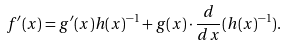Convert formula to latex. <formula><loc_0><loc_0><loc_500><loc_500>f ^ { \prime } ( x ) = g ^ { \prime } ( x ) h ( x ) ^ { - 1 } + g ( x ) \cdot { \frac { d } { d x } } ( h ( x ) ^ { - 1 } ) .</formula> 